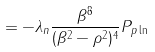Convert formula to latex. <formula><loc_0><loc_0><loc_500><loc_500>= - \lambda _ { n } \frac { \beta ^ { 8 } } { ( \beta ^ { 2 } - \rho ^ { 2 } ) ^ { 4 } } P _ { p \ln }</formula> 